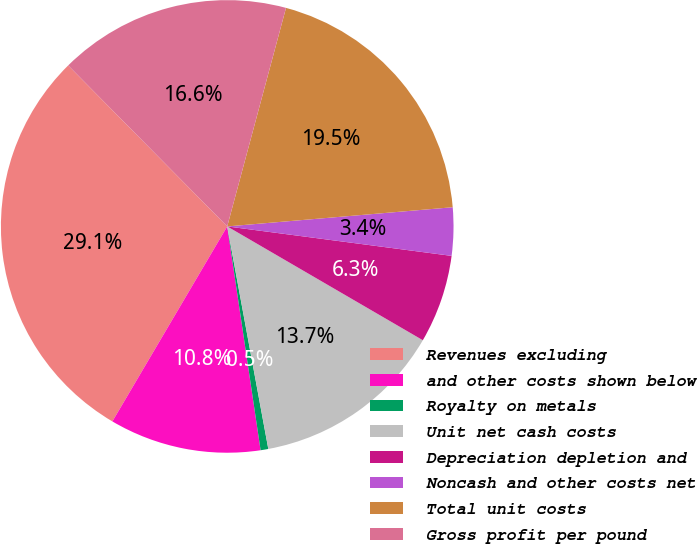Convert chart to OTSL. <chart><loc_0><loc_0><loc_500><loc_500><pie_chart><fcel>Revenues excluding<fcel>and other costs shown below<fcel>Royalty on metals<fcel>Unit net cash costs<fcel>Depreciation depletion and<fcel>Noncash and other costs net<fcel>Total unit costs<fcel>Gross profit per pound<nl><fcel>29.13%<fcel>10.83%<fcel>0.55%<fcel>13.71%<fcel>6.31%<fcel>3.43%<fcel>19.47%<fcel>16.59%<nl></chart> 